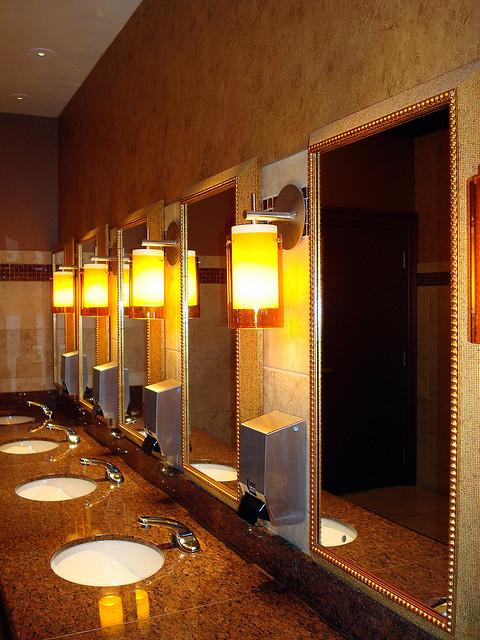How many lights are on?
Be succinct. 4. What color are the taps?
Quick response, please. Silver. Are the mirrors gold-plated?
Answer briefly. Yes. 